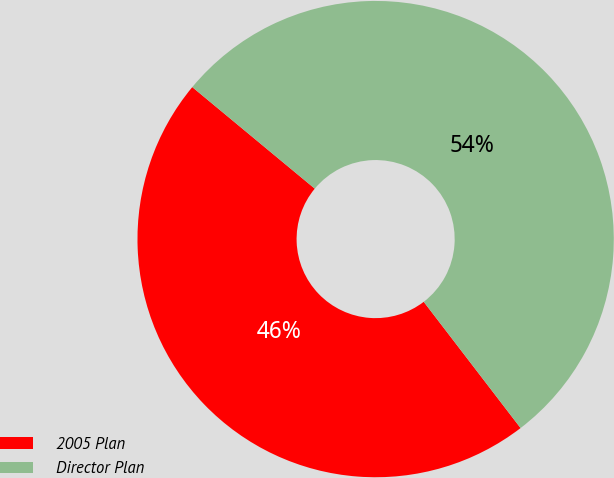<chart> <loc_0><loc_0><loc_500><loc_500><pie_chart><fcel>2005 Plan<fcel>Director Plan<nl><fcel>46.43%<fcel>53.57%<nl></chart> 